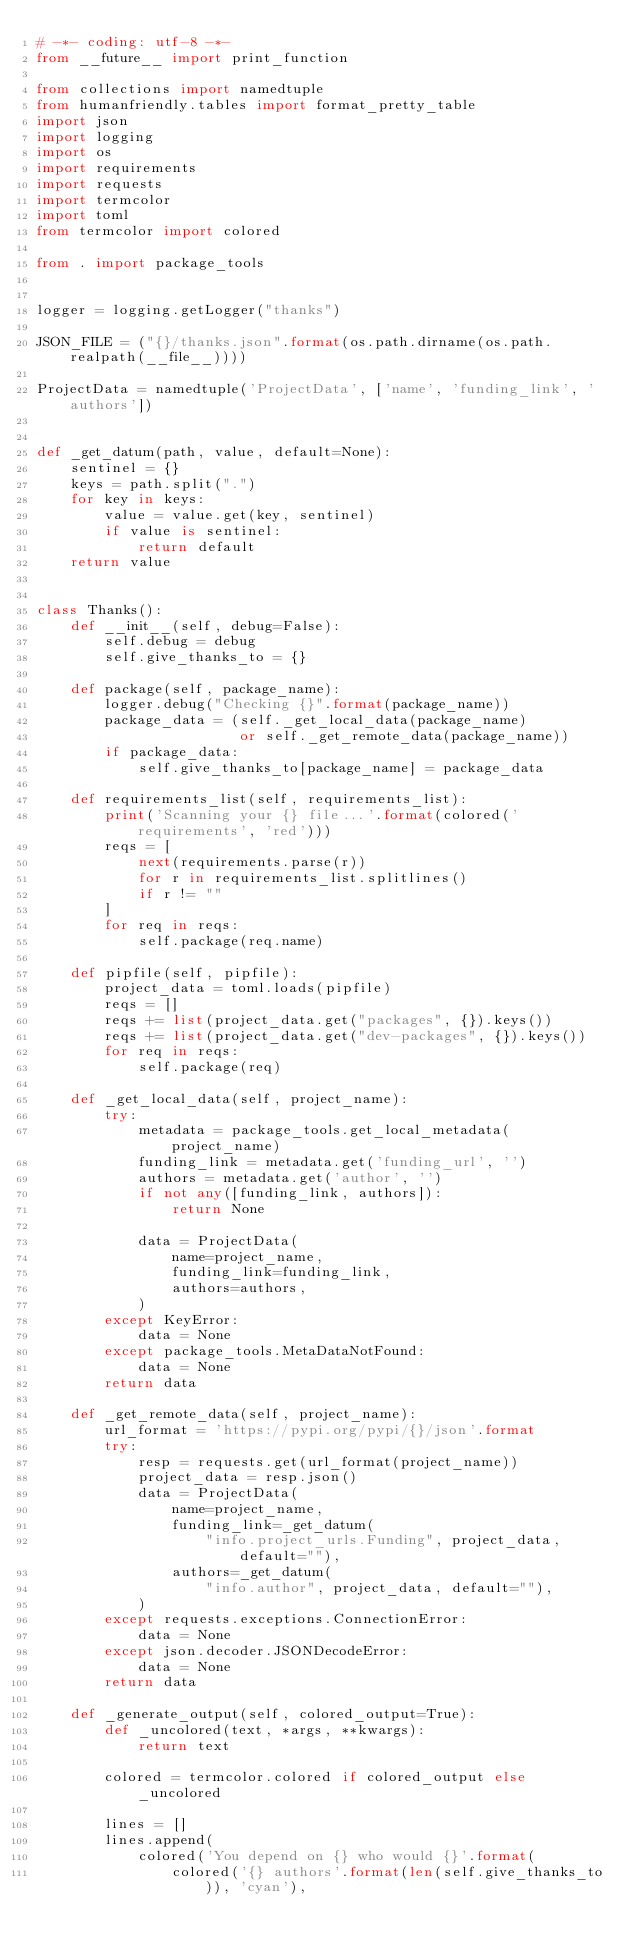<code> <loc_0><loc_0><loc_500><loc_500><_Python_># -*- coding: utf-8 -*-
from __future__ import print_function

from collections import namedtuple
from humanfriendly.tables import format_pretty_table
import json
import logging
import os
import requirements
import requests
import termcolor
import toml
from termcolor import colored

from . import package_tools


logger = logging.getLogger("thanks")

JSON_FILE = ("{}/thanks.json".format(os.path.dirname(os.path.realpath(__file__))))

ProjectData = namedtuple('ProjectData', ['name', 'funding_link', 'authors'])


def _get_datum(path, value, default=None):
    sentinel = {}
    keys = path.split(".")
    for key in keys:
        value = value.get(key, sentinel)
        if value is sentinel:
            return default
    return value


class Thanks():
    def __init__(self, debug=False):
        self.debug = debug
        self.give_thanks_to = {}

    def package(self, package_name):
        logger.debug("Checking {}".format(package_name))
        package_data = (self._get_local_data(package_name)
                        or self._get_remote_data(package_name))
        if package_data:
            self.give_thanks_to[package_name] = package_data

    def requirements_list(self, requirements_list):
        print('Scanning your {} file...'.format(colored('requirements', 'red')))
        reqs = [
            next(requirements.parse(r))
            for r in requirements_list.splitlines()
            if r != ""
        ]
        for req in reqs:
            self.package(req.name)

    def pipfile(self, pipfile):
        project_data = toml.loads(pipfile)
        reqs = []
        reqs += list(project_data.get("packages", {}).keys())
        reqs += list(project_data.get("dev-packages", {}).keys())
        for req in reqs:
            self.package(req)

    def _get_local_data(self, project_name):
        try:
            metadata = package_tools.get_local_metadata(project_name)
            funding_link = metadata.get('funding_url', '')
            authors = metadata.get('author', '')
            if not any([funding_link, authors]):
                return None

            data = ProjectData(
                name=project_name,
                funding_link=funding_link,
                authors=authors,
            )
        except KeyError:
            data = None
        except package_tools.MetaDataNotFound:
            data = None
        return data

    def _get_remote_data(self, project_name):
        url_format = 'https://pypi.org/pypi/{}/json'.format
        try:
            resp = requests.get(url_format(project_name))
            project_data = resp.json()
            data = ProjectData(
                name=project_name,
                funding_link=_get_datum(
                    "info.project_urls.Funding", project_data, default=""),
                authors=_get_datum(
                    "info.author", project_data, default=""),
            )
        except requests.exceptions.ConnectionError:
            data = None
        except json.decoder.JSONDecodeError:
            data = None
        return data

    def _generate_output(self, colored_output=True):
        def _uncolored(text, *args, **kwargs):
            return text

        colored = termcolor.colored if colored_output else _uncolored

        lines = []
        lines.append(
            colored('You depend on {} who would {}'.format(
                colored('{} authors'.format(len(self.give_thanks_to)), 'cyan'),</code> 